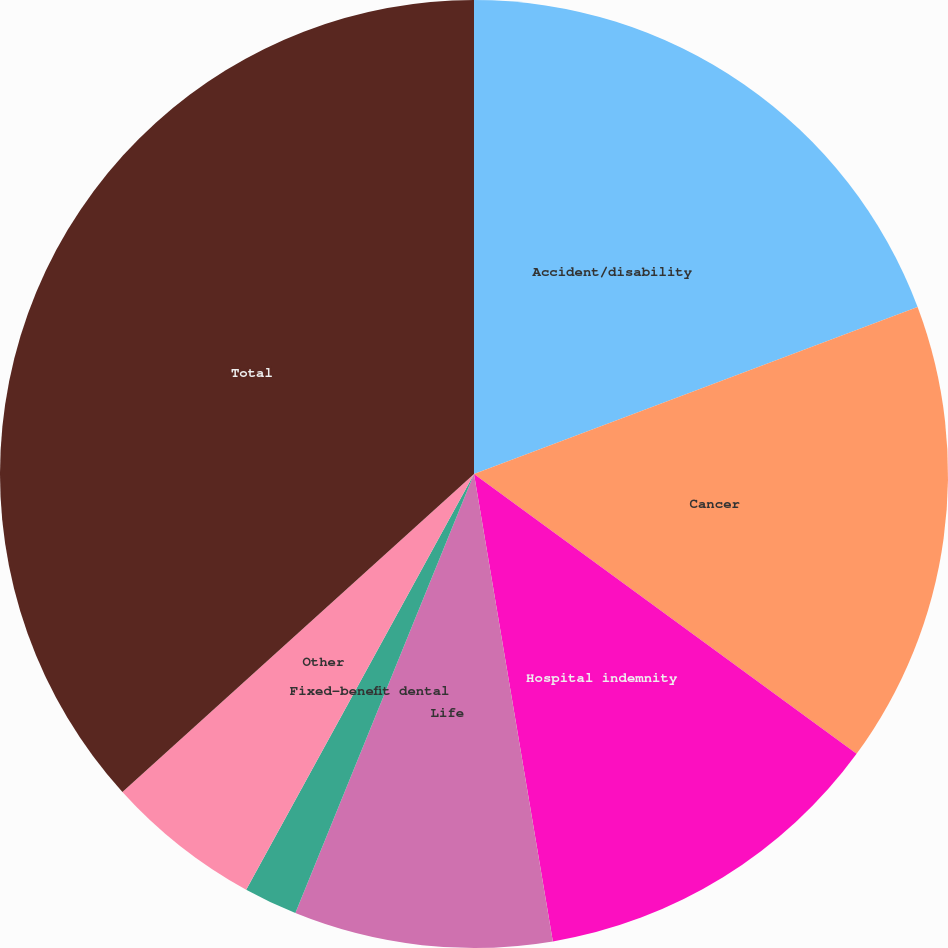Convert chart. <chart><loc_0><loc_0><loc_500><loc_500><pie_chart><fcel>Accident/disability<fcel>Cancer<fcel>Hospital indemnity<fcel>Life<fcel>Fixed-benefit dental<fcel>Other<fcel>Total<nl><fcel>19.27%<fcel>15.78%<fcel>12.29%<fcel>8.81%<fcel>1.83%<fcel>5.32%<fcel>36.7%<nl></chart> 